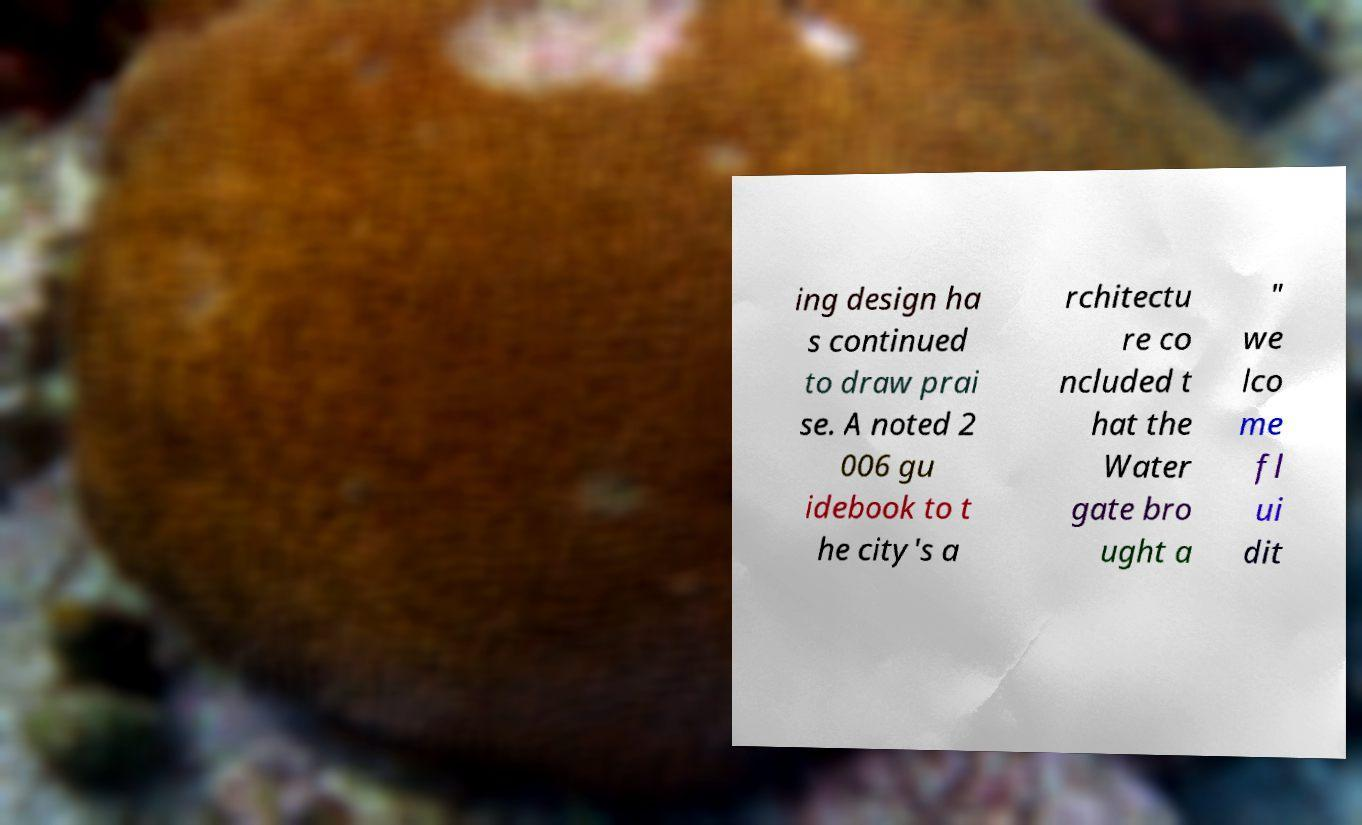I need the written content from this picture converted into text. Can you do that? ing design ha s continued to draw prai se. A noted 2 006 gu idebook to t he city's a rchitectu re co ncluded t hat the Water gate bro ught a " we lco me fl ui dit 